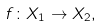<formula> <loc_0><loc_0><loc_500><loc_500>f \colon X _ { 1 } \to X _ { 2 } ,</formula> 